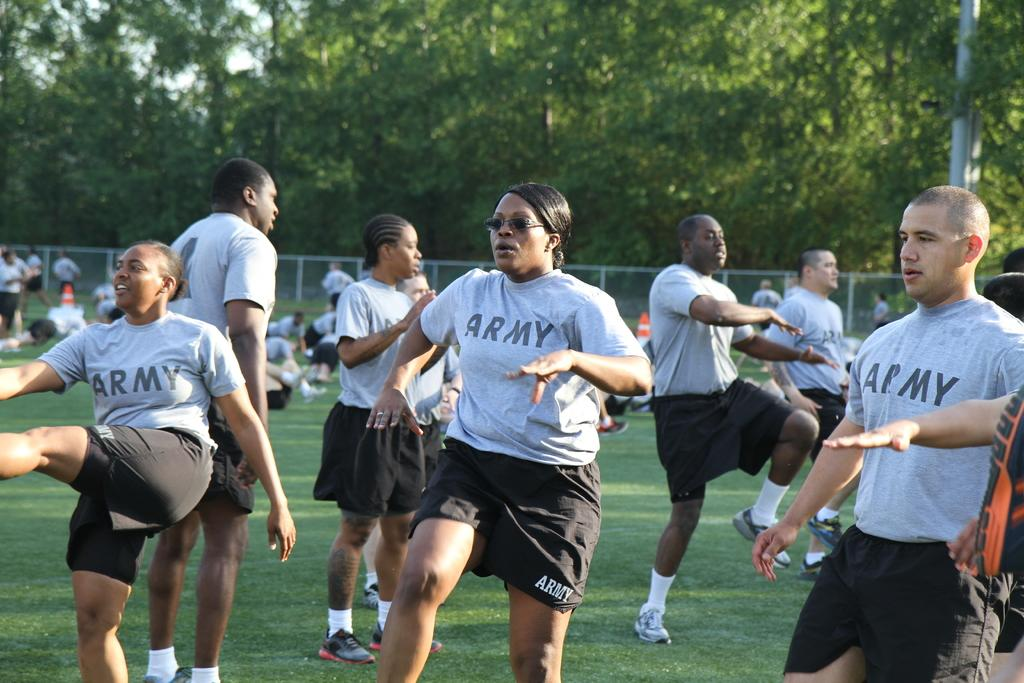What are the people in the image doing? The people in the image are on the grass. What can be seen on the right side of the image? There is a pole on the right side of the image. What is visible in the background of the image? There are trees in the background of the image. What type of glue is being used by the people in the image? There is no glue present in the image, and the people are not using any glue. How many icicles can be seen hanging from the trees in the image? There are no icicles present in the image, as it is not a winter scene and the trees are not covered in ice. 